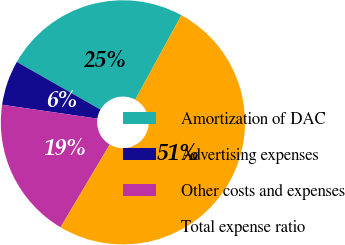Convert chart to OTSL. <chart><loc_0><loc_0><loc_500><loc_500><pie_chart><fcel>Amortization of DAC<fcel>Advertising expenses<fcel>Other costs and expenses<fcel>Total expense ratio<nl><fcel>24.71%<fcel>5.94%<fcel>18.77%<fcel>50.57%<nl></chart> 